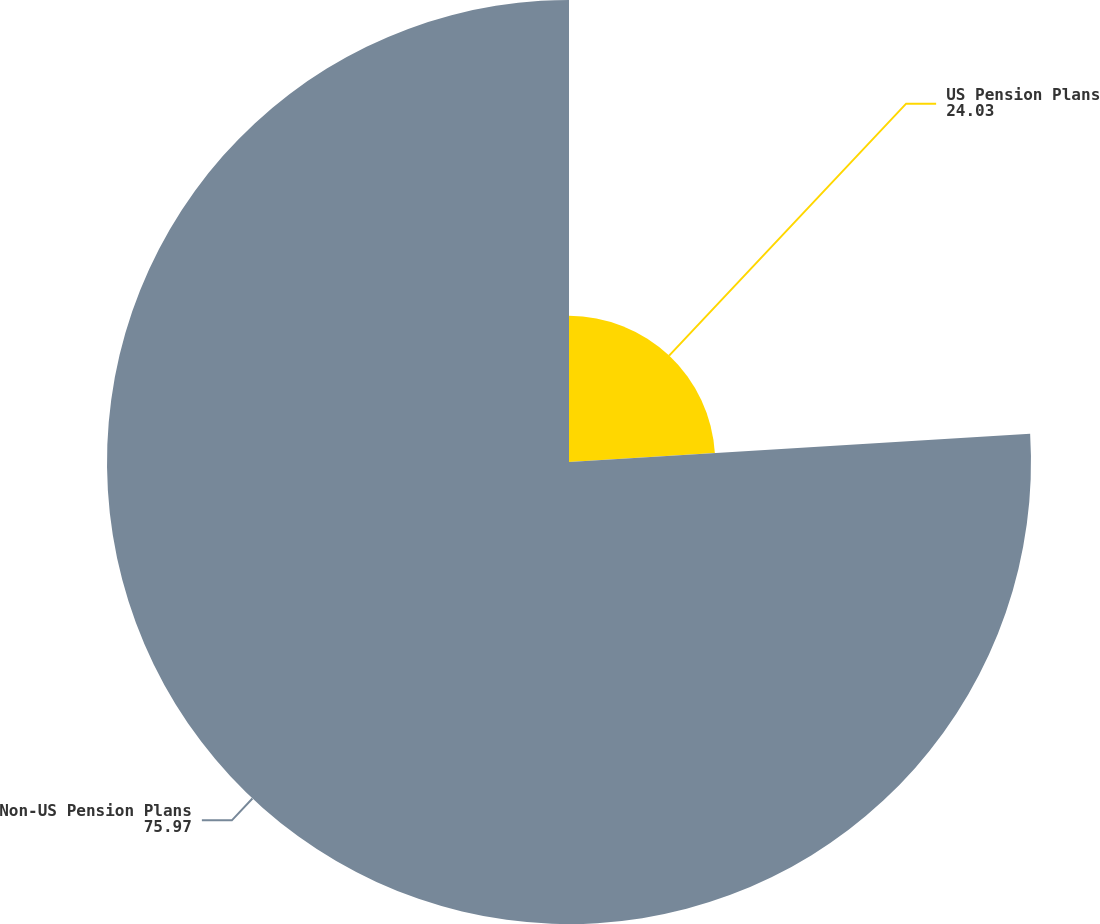<chart> <loc_0><loc_0><loc_500><loc_500><pie_chart><fcel>US Pension Plans<fcel>Non-US Pension Plans<nl><fcel>24.03%<fcel>75.97%<nl></chart> 